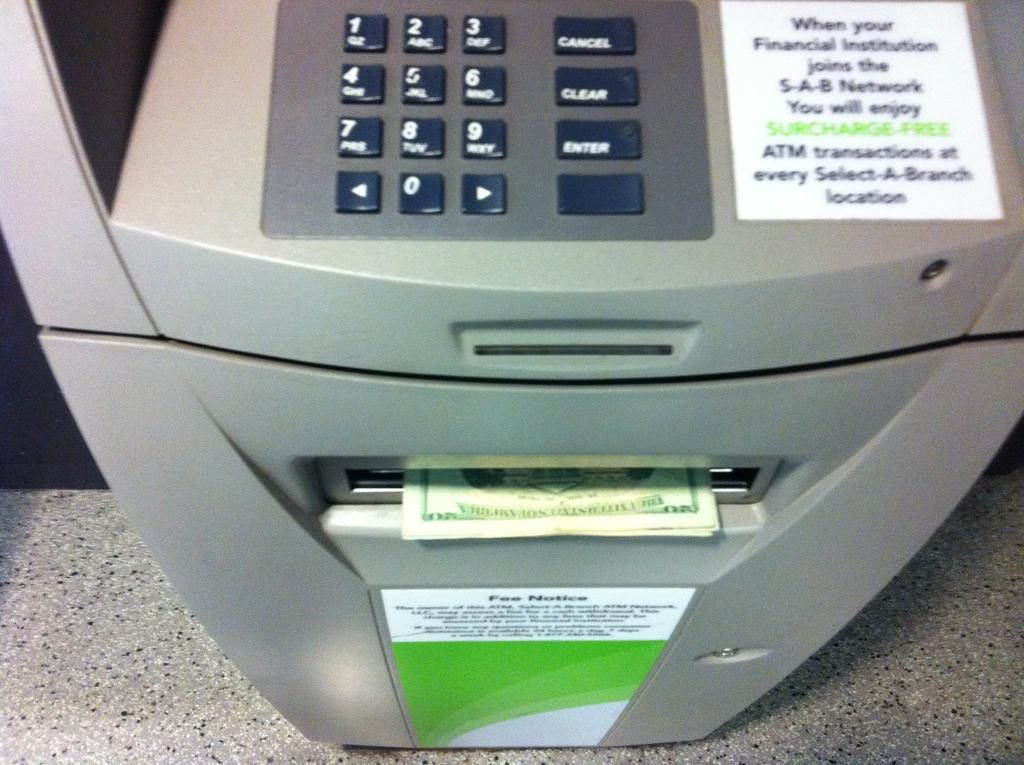<image>
Give a short and clear explanation of the subsequent image. An ATM machine on which the word cancel can be seen one a button. 